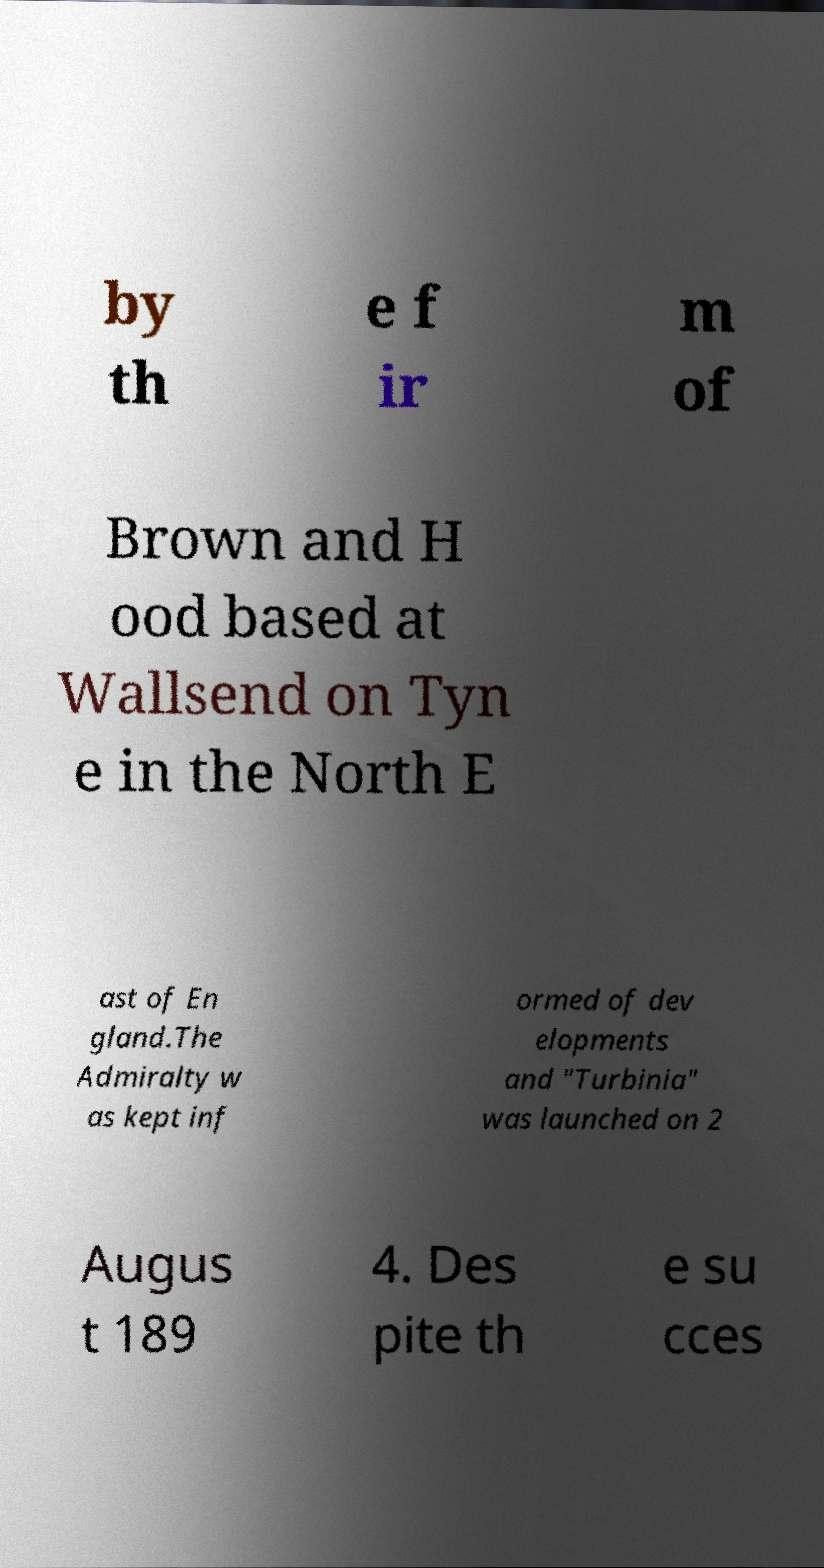I need the written content from this picture converted into text. Can you do that? by th e f ir m of Brown and H ood based at Wallsend on Tyn e in the North E ast of En gland.The Admiralty w as kept inf ormed of dev elopments and "Turbinia" was launched on 2 Augus t 189 4. Des pite th e su cces 